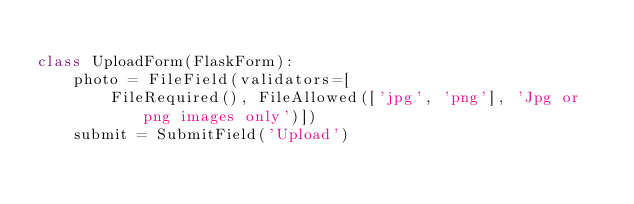Convert code to text. <code><loc_0><loc_0><loc_500><loc_500><_Python_>
class UploadForm(FlaskForm):
    photo = FileField(validators=[
        FileRequired(), FileAllowed(['jpg', 'png'], 'Jpg or png images only')])
    submit = SubmitField('Upload')
</code> 